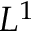Convert formula to latex. <formula><loc_0><loc_0><loc_500><loc_500>L ^ { 1 }</formula> 